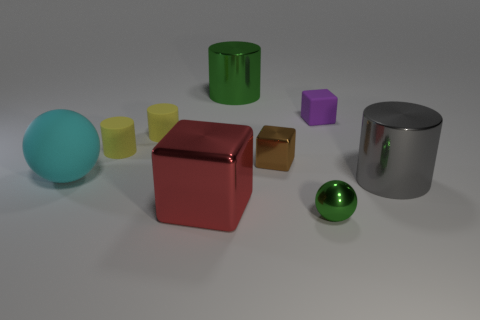What size is the metal object that is right of the matte block?
Ensure brevity in your answer.  Large. There is a object that is the same color as the shiny sphere; what is it made of?
Offer a terse response. Metal. There is a shiny cube that is the same size as the purple rubber thing; what is its color?
Give a very brief answer. Brown. Do the gray metal cylinder and the red shiny block have the same size?
Your response must be concise. Yes. How big is the cylinder that is on the right side of the large red thing and left of the big gray metallic cylinder?
Your answer should be compact. Large. What number of matte objects are either big red cubes or green things?
Ensure brevity in your answer.  0. Are there more small brown shiny things behind the large metal cube than big green matte cubes?
Make the answer very short. Yes. There is a big thing that is to the left of the big red shiny thing; what material is it?
Offer a very short reply. Rubber. What number of green cylinders have the same material as the large ball?
Offer a terse response. 0. The large metal thing that is on the left side of the small green object and on the right side of the red metal object has what shape?
Provide a short and direct response. Cylinder. 